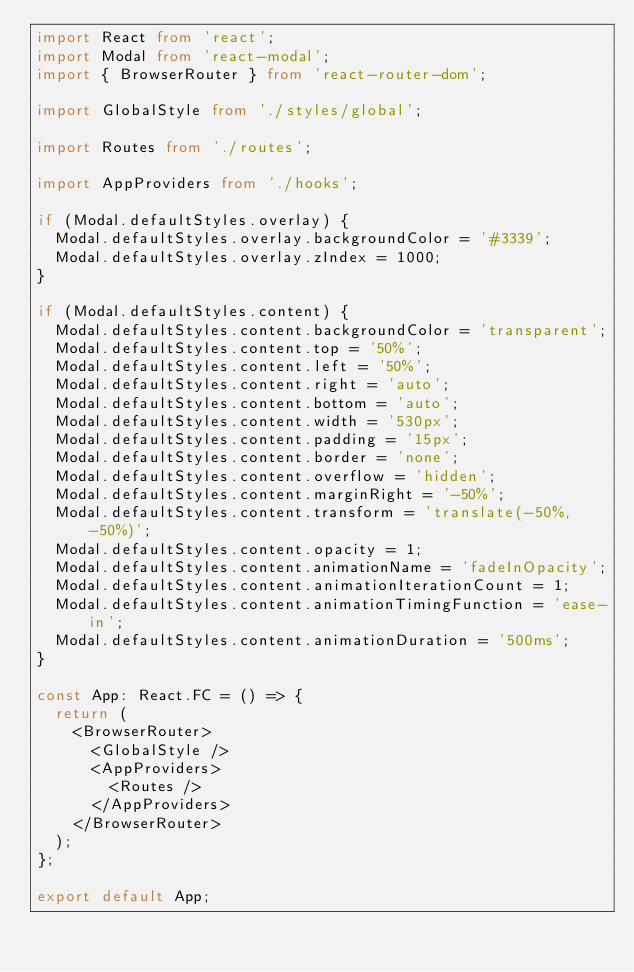<code> <loc_0><loc_0><loc_500><loc_500><_TypeScript_>import React from 'react';
import Modal from 'react-modal';
import { BrowserRouter } from 'react-router-dom';

import GlobalStyle from './styles/global';

import Routes from './routes';

import AppProviders from './hooks';

if (Modal.defaultStyles.overlay) {
  Modal.defaultStyles.overlay.backgroundColor = '#3339';
  Modal.defaultStyles.overlay.zIndex = 1000;
}

if (Modal.defaultStyles.content) {
  Modal.defaultStyles.content.backgroundColor = 'transparent';
  Modal.defaultStyles.content.top = '50%';
  Modal.defaultStyles.content.left = '50%';
  Modal.defaultStyles.content.right = 'auto';
  Modal.defaultStyles.content.bottom = 'auto';
  Modal.defaultStyles.content.width = '530px';
  Modal.defaultStyles.content.padding = '15px';
  Modal.defaultStyles.content.border = 'none';
  Modal.defaultStyles.content.overflow = 'hidden';
  Modal.defaultStyles.content.marginRight = '-50%';
  Modal.defaultStyles.content.transform = 'translate(-50%, -50%)';
  Modal.defaultStyles.content.opacity = 1;
  Modal.defaultStyles.content.animationName = 'fadeInOpacity';
  Modal.defaultStyles.content.animationIterationCount = 1;
  Modal.defaultStyles.content.animationTimingFunction = 'ease-in';
  Modal.defaultStyles.content.animationDuration = '500ms';
}

const App: React.FC = () => {
  return (
    <BrowserRouter>
      <GlobalStyle />
      <AppProviders>
        <Routes />
      </AppProviders>
    </BrowserRouter>
  );
};

export default App;
</code> 